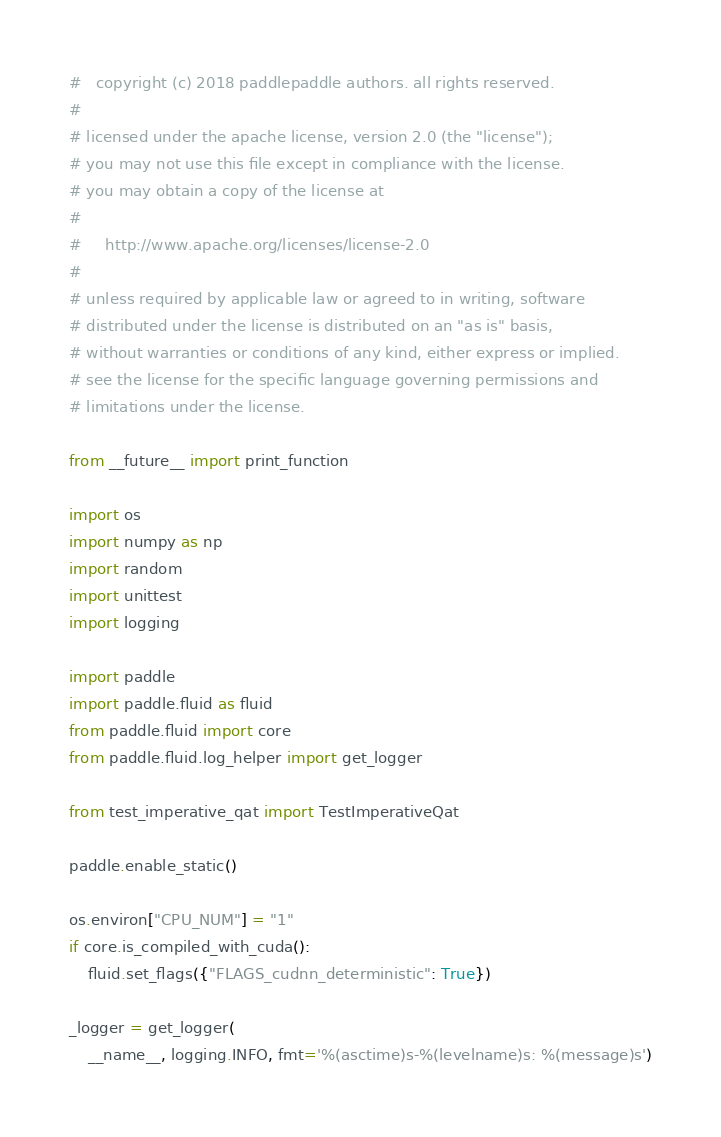Convert code to text. <code><loc_0><loc_0><loc_500><loc_500><_Python_>#   copyright (c) 2018 paddlepaddle authors. all rights reserved.
#
# licensed under the apache license, version 2.0 (the "license");
# you may not use this file except in compliance with the license.
# you may obtain a copy of the license at
#
#     http://www.apache.org/licenses/license-2.0
#
# unless required by applicable law or agreed to in writing, software
# distributed under the license is distributed on an "as is" basis,
# without warranties or conditions of any kind, either express or implied.
# see the license for the specific language governing permissions and
# limitations under the license.

from __future__ import print_function

import os
import numpy as np
import random
import unittest
import logging

import paddle
import paddle.fluid as fluid
from paddle.fluid import core
from paddle.fluid.log_helper import get_logger

from test_imperative_qat import TestImperativeQat

paddle.enable_static()

os.environ["CPU_NUM"] = "1"
if core.is_compiled_with_cuda():
    fluid.set_flags({"FLAGS_cudnn_deterministic": True})

_logger = get_logger(
    __name__, logging.INFO, fmt='%(asctime)s-%(levelname)s: %(message)s')

</code> 